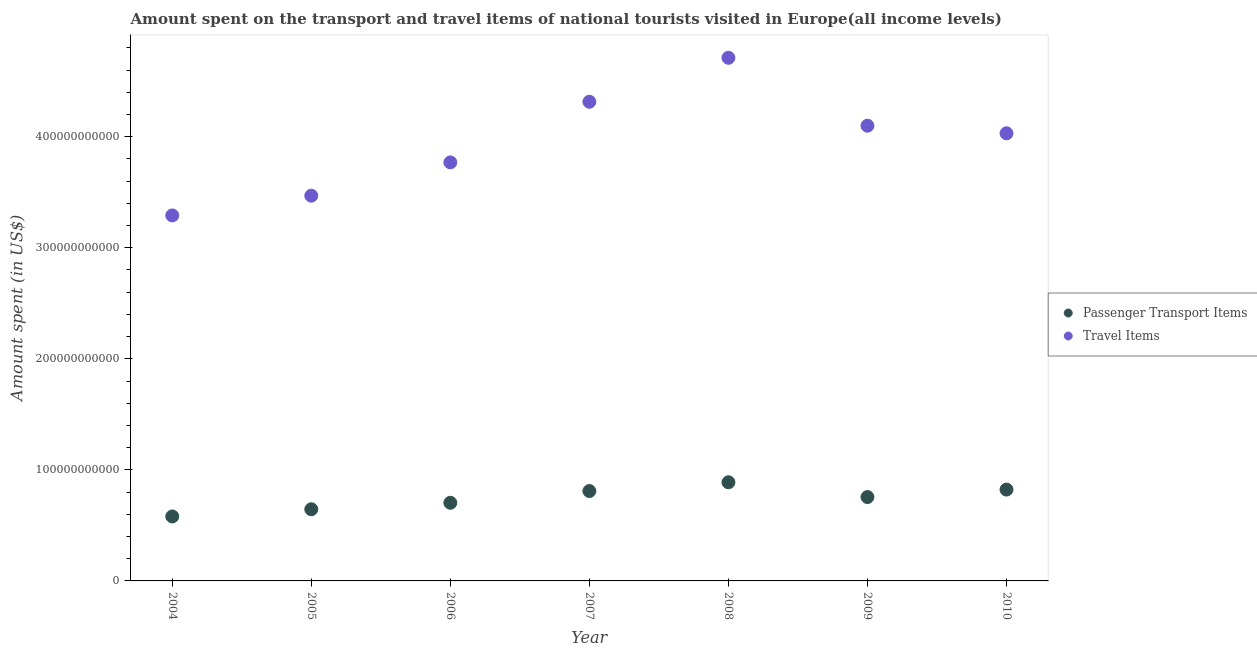How many different coloured dotlines are there?
Your answer should be compact. 2. What is the amount spent in travel items in 2007?
Your answer should be compact. 4.31e+11. Across all years, what is the maximum amount spent in travel items?
Provide a succinct answer. 4.71e+11. Across all years, what is the minimum amount spent in travel items?
Give a very brief answer. 3.29e+11. What is the total amount spent on passenger transport items in the graph?
Offer a terse response. 5.20e+11. What is the difference between the amount spent in travel items in 2006 and that in 2007?
Your answer should be compact. -5.46e+1. What is the difference between the amount spent on passenger transport items in 2010 and the amount spent in travel items in 2008?
Your response must be concise. -3.89e+11. What is the average amount spent in travel items per year?
Provide a succinct answer. 3.95e+11. In the year 2007, what is the difference between the amount spent on passenger transport items and amount spent in travel items?
Ensure brevity in your answer.  -3.51e+11. In how many years, is the amount spent on passenger transport items greater than 140000000000 US$?
Your answer should be very brief. 0. What is the ratio of the amount spent in travel items in 2008 to that in 2010?
Your answer should be very brief. 1.17. Is the amount spent in travel items in 2004 less than that in 2010?
Offer a very short reply. Yes. Is the difference between the amount spent on passenger transport items in 2004 and 2009 greater than the difference between the amount spent in travel items in 2004 and 2009?
Offer a terse response. Yes. What is the difference between the highest and the second highest amount spent on passenger transport items?
Your answer should be very brief. 6.58e+09. What is the difference between the highest and the lowest amount spent in travel items?
Your answer should be very brief. 1.42e+11. Does the amount spent on passenger transport items monotonically increase over the years?
Offer a terse response. No. Is the amount spent in travel items strictly less than the amount spent on passenger transport items over the years?
Provide a short and direct response. No. How many years are there in the graph?
Keep it short and to the point. 7. What is the difference between two consecutive major ticks on the Y-axis?
Give a very brief answer. 1.00e+11. Does the graph contain grids?
Offer a very short reply. No. Where does the legend appear in the graph?
Provide a succinct answer. Center right. How are the legend labels stacked?
Your answer should be compact. Vertical. What is the title of the graph?
Offer a terse response. Amount spent on the transport and travel items of national tourists visited in Europe(all income levels). What is the label or title of the X-axis?
Your answer should be compact. Year. What is the label or title of the Y-axis?
Offer a very short reply. Amount spent (in US$). What is the Amount spent (in US$) of Passenger Transport Items in 2004?
Keep it short and to the point. 5.81e+1. What is the Amount spent (in US$) in Travel Items in 2004?
Give a very brief answer. 3.29e+11. What is the Amount spent (in US$) of Passenger Transport Items in 2005?
Ensure brevity in your answer.  6.45e+1. What is the Amount spent (in US$) in Travel Items in 2005?
Give a very brief answer. 3.47e+11. What is the Amount spent (in US$) in Passenger Transport Items in 2006?
Give a very brief answer. 7.04e+1. What is the Amount spent (in US$) in Travel Items in 2006?
Keep it short and to the point. 3.77e+11. What is the Amount spent (in US$) in Passenger Transport Items in 2007?
Your answer should be compact. 8.09e+1. What is the Amount spent (in US$) of Travel Items in 2007?
Make the answer very short. 4.31e+11. What is the Amount spent (in US$) of Passenger Transport Items in 2008?
Offer a very short reply. 8.88e+1. What is the Amount spent (in US$) of Travel Items in 2008?
Offer a very short reply. 4.71e+11. What is the Amount spent (in US$) of Passenger Transport Items in 2009?
Your response must be concise. 7.55e+1. What is the Amount spent (in US$) in Travel Items in 2009?
Your response must be concise. 4.10e+11. What is the Amount spent (in US$) of Passenger Transport Items in 2010?
Provide a short and direct response. 8.22e+1. What is the Amount spent (in US$) of Travel Items in 2010?
Give a very brief answer. 4.03e+11. Across all years, what is the maximum Amount spent (in US$) in Passenger Transport Items?
Offer a very short reply. 8.88e+1. Across all years, what is the maximum Amount spent (in US$) in Travel Items?
Make the answer very short. 4.71e+11. Across all years, what is the minimum Amount spent (in US$) in Passenger Transport Items?
Offer a terse response. 5.81e+1. Across all years, what is the minimum Amount spent (in US$) of Travel Items?
Offer a terse response. 3.29e+11. What is the total Amount spent (in US$) in Passenger Transport Items in the graph?
Provide a succinct answer. 5.20e+11. What is the total Amount spent (in US$) in Travel Items in the graph?
Ensure brevity in your answer.  2.77e+12. What is the difference between the Amount spent (in US$) of Passenger Transport Items in 2004 and that in 2005?
Offer a very short reply. -6.48e+09. What is the difference between the Amount spent (in US$) of Travel Items in 2004 and that in 2005?
Provide a succinct answer. -1.78e+1. What is the difference between the Amount spent (in US$) in Passenger Transport Items in 2004 and that in 2006?
Offer a very short reply. -1.23e+1. What is the difference between the Amount spent (in US$) of Travel Items in 2004 and that in 2006?
Provide a short and direct response. -4.78e+1. What is the difference between the Amount spent (in US$) of Passenger Transport Items in 2004 and that in 2007?
Your answer should be very brief. -2.29e+1. What is the difference between the Amount spent (in US$) of Travel Items in 2004 and that in 2007?
Ensure brevity in your answer.  -1.02e+11. What is the difference between the Amount spent (in US$) in Passenger Transport Items in 2004 and that in 2008?
Keep it short and to the point. -3.08e+1. What is the difference between the Amount spent (in US$) in Travel Items in 2004 and that in 2008?
Offer a very short reply. -1.42e+11. What is the difference between the Amount spent (in US$) in Passenger Transport Items in 2004 and that in 2009?
Your response must be concise. -1.75e+1. What is the difference between the Amount spent (in US$) of Travel Items in 2004 and that in 2009?
Your response must be concise. -8.08e+1. What is the difference between the Amount spent (in US$) in Passenger Transport Items in 2004 and that in 2010?
Make the answer very short. -2.42e+1. What is the difference between the Amount spent (in US$) in Travel Items in 2004 and that in 2010?
Keep it short and to the point. -7.39e+1. What is the difference between the Amount spent (in US$) in Passenger Transport Items in 2005 and that in 2006?
Provide a succinct answer. -5.84e+09. What is the difference between the Amount spent (in US$) in Travel Items in 2005 and that in 2006?
Give a very brief answer. -3.00e+1. What is the difference between the Amount spent (in US$) of Passenger Transport Items in 2005 and that in 2007?
Your response must be concise. -1.64e+1. What is the difference between the Amount spent (in US$) in Travel Items in 2005 and that in 2007?
Offer a very short reply. -8.46e+1. What is the difference between the Amount spent (in US$) in Passenger Transport Items in 2005 and that in 2008?
Offer a very short reply. -2.43e+1. What is the difference between the Amount spent (in US$) of Travel Items in 2005 and that in 2008?
Provide a succinct answer. -1.24e+11. What is the difference between the Amount spent (in US$) in Passenger Transport Items in 2005 and that in 2009?
Make the answer very short. -1.10e+1. What is the difference between the Amount spent (in US$) of Travel Items in 2005 and that in 2009?
Your answer should be very brief. -6.30e+1. What is the difference between the Amount spent (in US$) in Passenger Transport Items in 2005 and that in 2010?
Make the answer very short. -1.77e+1. What is the difference between the Amount spent (in US$) of Travel Items in 2005 and that in 2010?
Keep it short and to the point. -5.62e+1. What is the difference between the Amount spent (in US$) of Passenger Transport Items in 2006 and that in 2007?
Offer a terse response. -1.06e+1. What is the difference between the Amount spent (in US$) in Travel Items in 2006 and that in 2007?
Provide a short and direct response. -5.46e+1. What is the difference between the Amount spent (in US$) of Passenger Transport Items in 2006 and that in 2008?
Offer a very short reply. -1.85e+1. What is the difference between the Amount spent (in US$) of Travel Items in 2006 and that in 2008?
Give a very brief answer. -9.42e+1. What is the difference between the Amount spent (in US$) of Passenger Transport Items in 2006 and that in 2009?
Keep it short and to the point. -5.15e+09. What is the difference between the Amount spent (in US$) of Travel Items in 2006 and that in 2009?
Provide a short and direct response. -3.30e+1. What is the difference between the Amount spent (in US$) of Passenger Transport Items in 2006 and that in 2010?
Give a very brief answer. -1.19e+1. What is the difference between the Amount spent (in US$) of Travel Items in 2006 and that in 2010?
Your answer should be very brief. -2.62e+1. What is the difference between the Amount spent (in US$) of Passenger Transport Items in 2007 and that in 2008?
Keep it short and to the point. -7.91e+09. What is the difference between the Amount spent (in US$) of Travel Items in 2007 and that in 2008?
Ensure brevity in your answer.  -3.96e+1. What is the difference between the Amount spent (in US$) of Passenger Transport Items in 2007 and that in 2009?
Offer a very short reply. 5.40e+09. What is the difference between the Amount spent (in US$) in Travel Items in 2007 and that in 2009?
Provide a succinct answer. 2.16e+1. What is the difference between the Amount spent (in US$) in Passenger Transport Items in 2007 and that in 2010?
Give a very brief answer. -1.33e+09. What is the difference between the Amount spent (in US$) of Travel Items in 2007 and that in 2010?
Give a very brief answer. 2.84e+1. What is the difference between the Amount spent (in US$) of Passenger Transport Items in 2008 and that in 2009?
Offer a terse response. 1.33e+1. What is the difference between the Amount spent (in US$) of Travel Items in 2008 and that in 2009?
Provide a succinct answer. 6.11e+1. What is the difference between the Amount spent (in US$) of Passenger Transport Items in 2008 and that in 2010?
Make the answer very short. 6.58e+09. What is the difference between the Amount spent (in US$) in Travel Items in 2008 and that in 2010?
Provide a short and direct response. 6.80e+1. What is the difference between the Amount spent (in US$) in Passenger Transport Items in 2009 and that in 2010?
Your response must be concise. -6.73e+09. What is the difference between the Amount spent (in US$) of Travel Items in 2009 and that in 2010?
Provide a short and direct response. 6.83e+09. What is the difference between the Amount spent (in US$) of Passenger Transport Items in 2004 and the Amount spent (in US$) of Travel Items in 2005?
Give a very brief answer. -2.89e+11. What is the difference between the Amount spent (in US$) of Passenger Transport Items in 2004 and the Amount spent (in US$) of Travel Items in 2006?
Your response must be concise. -3.19e+11. What is the difference between the Amount spent (in US$) of Passenger Transport Items in 2004 and the Amount spent (in US$) of Travel Items in 2007?
Ensure brevity in your answer.  -3.73e+11. What is the difference between the Amount spent (in US$) in Passenger Transport Items in 2004 and the Amount spent (in US$) in Travel Items in 2008?
Make the answer very short. -4.13e+11. What is the difference between the Amount spent (in US$) in Passenger Transport Items in 2004 and the Amount spent (in US$) in Travel Items in 2009?
Offer a terse response. -3.52e+11. What is the difference between the Amount spent (in US$) in Passenger Transport Items in 2004 and the Amount spent (in US$) in Travel Items in 2010?
Provide a short and direct response. -3.45e+11. What is the difference between the Amount spent (in US$) in Passenger Transport Items in 2005 and the Amount spent (in US$) in Travel Items in 2006?
Give a very brief answer. -3.12e+11. What is the difference between the Amount spent (in US$) in Passenger Transport Items in 2005 and the Amount spent (in US$) in Travel Items in 2007?
Offer a terse response. -3.67e+11. What is the difference between the Amount spent (in US$) in Passenger Transport Items in 2005 and the Amount spent (in US$) in Travel Items in 2008?
Offer a terse response. -4.06e+11. What is the difference between the Amount spent (in US$) of Passenger Transport Items in 2005 and the Amount spent (in US$) of Travel Items in 2009?
Make the answer very short. -3.45e+11. What is the difference between the Amount spent (in US$) in Passenger Transport Items in 2005 and the Amount spent (in US$) in Travel Items in 2010?
Provide a short and direct response. -3.39e+11. What is the difference between the Amount spent (in US$) of Passenger Transport Items in 2006 and the Amount spent (in US$) of Travel Items in 2007?
Make the answer very short. -3.61e+11. What is the difference between the Amount spent (in US$) in Passenger Transport Items in 2006 and the Amount spent (in US$) in Travel Items in 2008?
Keep it short and to the point. -4.01e+11. What is the difference between the Amount spent (in US$) of Passenger Transport Items in 2006 and the Amount spent (in US$) of Travel Items in 2009?
Keep it short and to the point. -3.39e+11. What is the difference between the Amount spent (in US$) of Passenger Transport Items in 2006 and the Amount spent (in US$) of Travel Items in 2010?
Provide a short and direct response. -3.33e+11. What is the difference between the Amount spent (in US$) in Passenger Transport Items in 2007 and the Amount spent (in US$) in Travel Items in 2008?
Give a very brief answer. -3.90e+11. What is the difference between the Amount spent (in US$) of Passenger Transport Items in 2007 and the Amount spent (in US$) of Travel Items in 2009?
Provide a short and direct response. -3.29e+11. What is the difference between the Amount spent (in US$) of Passenger Transport Items in 2007 and the Amount spent (in US$) of Travel Items in 2010?
Give a very brief answer. -3.22e+11. What is the difference between the Amount spent (in US$) in Passenger Transport Items in 2008 and the Amount spent (in US$) in Travel Items in 2009?
Provide a short and direct response. -3.21e+11. What is the difference between the Amount spent (in US$) in Passenger Transport Items in 2008 and the Amount spent (in US$) in Travel Items in 2010?
Your answer should be compact. -3.14e+11. What is the difference between the Amount spent (in US$) of Passenger Transport Items in 2009 and the Amount spent (in US$) of Travel Items in 2010?
Provide a succinct answer. -3.28e+11. What is the average Amount spent (in US$) in Passenger Transport Items per year?
Give a very brief answer. 7.43e+1. What is the average Amount spent (in US$) in Travel Items per year?
Give a very brief answer. 3.95e+11. In the year 2004, what is the difference between the Amount spent (in US$) of Passenger Transport Items and Amount spent (in US$) of Travel Items?
Your answer should be very brief. -2.71e+11. In the year 2005, what is the difference between the Amount spent (in US$) in Passenger Transport Items and Amount spent (in US$) in Travel Items?
Your answer should be compact. -2.82e+11. In the year 2006, what is the difference between the Amount spent (in US$) of Passenger Transport Items and Amount spent (in US$) of Travel Items?
Your response must be concise. -3.06e+11. In the year 2007, what is the difference between the Amount spent (in US$) in Passenger Transport Items and Amount spent (in US$) in Travel Items?
Provide a short and direct response. -3.51e+11. In the year 2008, what is the difference between the Amount spent (in US$) in Passenger Transport Items and Amount spent (in US$) in Travel Items?
Your answer should be very brief. -3.82e+11. In the year 2009, what is the difference between the Amount spent (in US$) in Passenger Transport Items and Amount spent (in US$) in Travel Items?
Your response must be concise. -3.34e+11. In the year 2010, what is the difference between the Amount spent (in US$) of Passenger Transport Items and Amount spent (in US$) of Travel Items?
Provide a short and direct response. -3.21e+11. What is the ratio of the Amount spent (in US$) in Passenger Transport Items in 2004 to that in 2005?
Provide a succinct answer. 0.9. What is the ratio of the Amount spent (in US$) of Travel Items in 2004 to that in 2005?
Offer a very short reply. 0.95. What is the ratio of the Amount spent (in US$) in Passenger Transport Items in 2004 to that in 2006?
Ensure brevity in your answer.  0.82. What is the ratio of the Amount spent (in US$) in Travel Items in 2004 to that in 2006?
Provide a succinct answer. 0.87. What is the ratio of the Amount spent (in US$) of Passenger Transport Items in 2004 to that in 2007?
Provide a short and direct response. 0.72. What is the ratio of the Amount spent (in US$) of Travel Items in 2004 to that in 2007?
Give a very brief answer. 0.76. What is the ratio of the Amount spent (in US$) in Passenger Transport Items in 2004 to that in 2008?
Offer a very short reply. 0.65. What is the ratio of the Amount spent (in US$) in Travel Items in 2004 to that in 2008?
Make the answer very short. 0.7. What is the ratio of the Amount spent (in US$) in Passenger Transport Items in 2004 to that in 2009?
Ensure brevity in your answer.  0.77. What is the ratio of the Amount spent (in US$) in Travel Items in 2004 to that in 2009?
Your response must be concise. 0.8. What is the ratio of the Amount spent (in US$) of Passenger Transport Items in 2004 to that in 2010?
Your answer should be compact. 0.71. What is the ratio of the Amount spent (in US$) of Travel Items in 2004 to that in 2010?
Your response must be concise. 0.82. What is the ratio of the Amount spent (in US$) in Passenger Transport Items in 2005 to that in 2006?
Give a very brief answer. 0.92. What is the ratio of the Amount spent (in US$) of Travel Items in 2005 to that in 2006?
Make the answer very short. 0.92. What is the ratio of the Amount spent (in US$) of Passenger Transport Items in 2005 to that in 2007?
Offer a terse response. 0.8. What is the ratio of the Amount spent (in US$) of Travel Items in 2005 to that in 2007?
Provide a succinct answer. 0.8. What is the ratio of the Amount spent (in US$) of Passenger Transport Items in 2005 to that in 2008?
Make the answer very short. 0.73. What is the ratio of the Amount spent (in US$) of Travel Items in 2005 to that in 2008?
Keep it short and to the point. 0.74. What is the ratio of the Amount spent (in US$) in Passenger Transport Items in 2005 to that in 2009?
Offer a very short reply. 0.85. What is the ratio of the Amount spent (in US$) in Travel Items in 2005 to that in 2009?
Ensure brevity in your answer.  0.85. What is the ratio of the Amount spent (in US$) of Passenger Transport Items in 2005 to that in 2010?
Provide a short and direct response. 0.78. What is the ratio of the Amount spent (in US$) in Travel Items in 2005 to that in 2010?
Provide a succinct answer. 0.86. What is the ratio of the Amount spent (in US$) in Passenger Transport Items in 2006 to that in 2007?
Make the answer very short. 0.87. What is the ratio of the Amount spent (in US$) of Travel Items in 2006 to that in 2007?
Provide a succinct answer. 0.87. What is the ratio of the Amount spent (in US$) of Passenger Transport Items in 2006 to that in 2008?
Give a very brief answer. 0.79. What is the ratio of the Amount spent (in US$) in Travel Items in 2006 to that in 2008?
Your answer should be compact. 0.8. What is the ratio of the Amount spent (in US$) in Passenger Transport Items in 2006 to that in 2009?
Provide a succinct answer. 0.93. What is the ratio of the Amount spent (in US$) in Travel Items in 2006 to that in 2009?
Give a very brief answer. 0.92. What is the ratio of the Amount spent (in US$) of Passenger Transport Items in 2006 to that in 2010?
Make the answer very short. 0.86. What is the ratio of the Amount spent (in US$) of Travel Items in 2006 to that in 2010?
Provide a short and direct response. 0.94. What is the ratio of the Amount spent (in US$) in Passenger Transport Items in 2007 to that in 2008?
Your answer should be very brief. 0.91. What is the ratio of the Amount spent (in US$) of Travel Items in 2007 to that in 2008?
Ensure brevity in your answer.  0.92. What is the ratio of the Amount spent (in US$) in Passenger Transport Items in 2007 to that in 2009?
Ensure brevity in your answer.  1.07. What is the ratio of the Amount spent (in US$) of Travel Items in 2007 to that in 2009?
Your answer should be very brief. 1.05. What is the ratio of the Amount spent (in US$) of Passenger Transport Items in 2007 to that in 2010?
Keep it short and to the point. 0.98. What is the ratio of the Amount spent (in US$) of Travel Items in 2007 to that in 2010?
Offer a terse response. 1.07. What is the ratio of the Amount spent (in US$) in Passenger Transport Items in 2008 to that in 2009?
Offer a very short reply. 1.18. What is the ratio of the Amount spent (in US$) in Travel Items in 2008 to that in 2009?
Your answer should be very brief. 1.15. What is the ratio of the Amount spent (in US$) in Passenger Transport Items in 2008 to that in 2010?
Give a very brief answer. 1.08. What is the ratio of the Amount spent (in US$) of Travel Items in 2008 to that in 2010?
Offer a very short reply. 1.17. What is the ratio of the Amount spent (in US$) of Passenger Transport Items in 2009 to that in 2010?
Your answer should be very brief. 0.92. What is the ratio of the Amount spent (in US$) in Travel Items in 2009 to that in 2010?
Ensure brevity in your answer.  1.02. What is the difference between the highest and the second highest Amount spent (in US$) in Passenger Transport Items?
Your answer should be compact. 6.58e+09. What is the difference between the highest and the second highest Amount spent (in US$) of Travel Items?
Offer a very short reply. 3.96e+1. What is the difference between the highest and the lowest Amount spent (in US$) of Passenger Transport Items?
Your answer should be very brief. 3.08e+1. What is the difference between the highest and the lowest Amount spent (in US$) in Travel Items?
Give a very brief answer. 1.42e+11. 